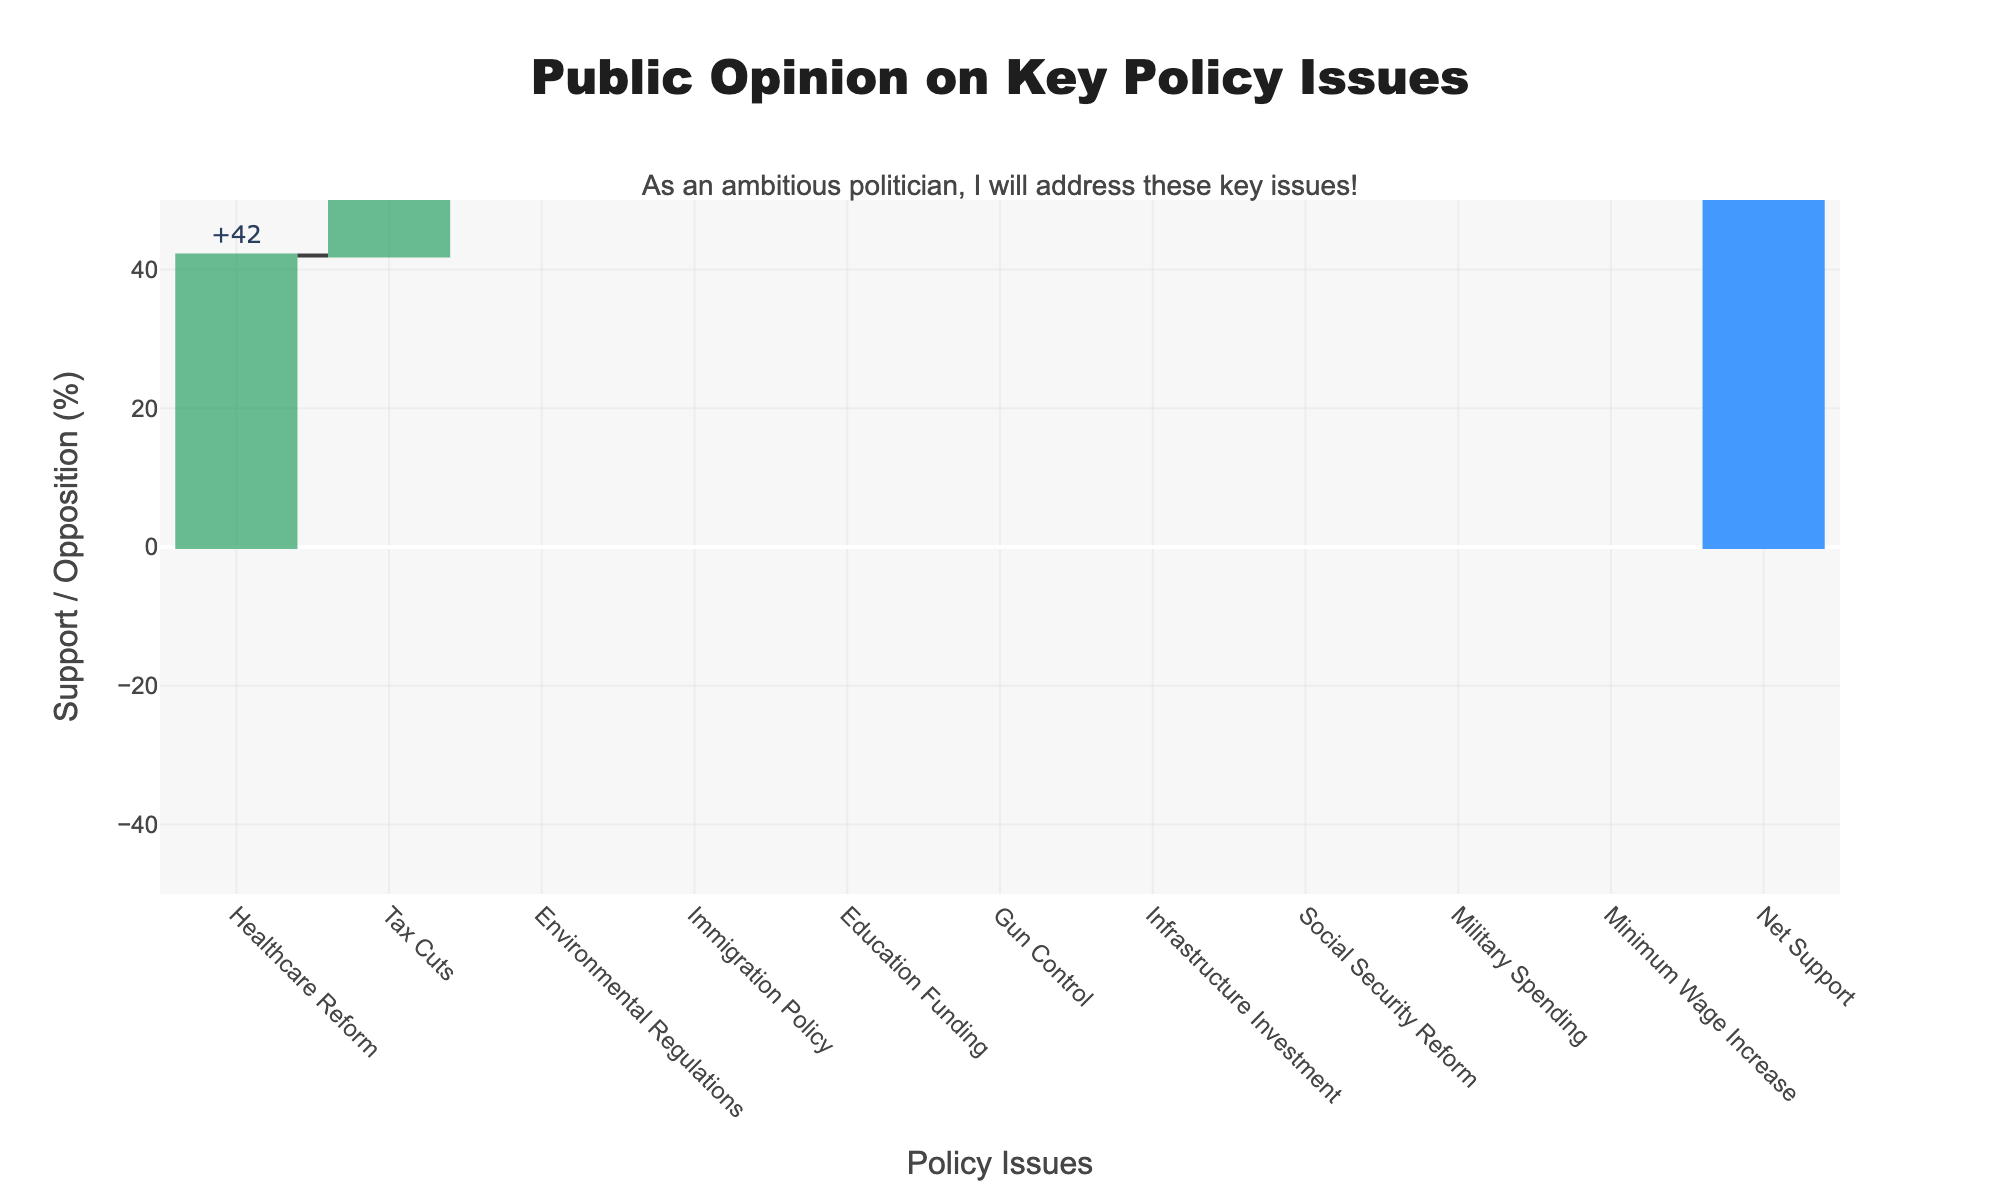What is the title of this chart? The title of the chart is located at the top center and reads "Public Opinion on Key Policy Issues".
Answer: Public Opinion on Key Policy Issues How many policy issues are shown in the figure? By counting the labels on the x-axis, we can see that there are ten policy issues listed.
Answer: Ten Which policy issue has the highest level of support? By comparing the green bars, which represent support, the tallest green bar corresponds to "Infrastructure Investment" with 48% support.
Answer: Infrastructure Investment What is the net support for "Immigration Policy"? Net support can be found by adding the support and opposition percentages for Immigration Policy. 31% (support) + (-39%) (opposition) = -8%.
Answer: -8% Is there any policy issue where opposition exceeds support? If so, name one. Analyzing the chart, we can see that "Gun Control" has a higher opposition value (-41%) compared to its support value (37%).
Answer: Gun Control What is the total net support across all policy issues? The total net support is provided in the last data point and can also be calculated by summing up the net support for all issues (Net Support). Total Net Support: (42 + 35 + 38 + 31 + 45 + 37 + 48 + 33 + 29 + 40) + (-38 -30 -33 -39 -25 -41 -22 -37 -34 -28) = 378 - 327 = 51%.
Answer: 51% Which policy issue has the closest net support to zero? By checking the hover text or calculating the net support for each issue, "Healthcare Reform" shows net support of 42% - 38% = 4%.
Answer: Healthcare Reform How does the total net support compare to the net support of "Minimum Wage Increase"? The total net support is 51%, while the net support for "Minimum Wage Increase" is 40% (support) + (-28%) (opposition) = 12%. Thus, the total net support is higher than "Minimum Wage Increase".
Answer: Total net support is higher Which policy issue has the lowest level of opposition? By comparing the red bars representing opposition, "Infrastructure Investment" has the shortest red bar with -22% opposition.
Answer: Infrastructure Investment Order the policy issues from highest to lowest net support. Calculate net support for each issue: Infrastructure Investment (26%), Education Funding (20%), Healthcare Reform (4%), Minimum Wage Increase (12%), Environmental Regulations (5%), Tax Cuts (5%), Gun Control (-4%), Social Security Reform (-4%), Immigration Policy (-8%), Military Spending (-5%). Ordered from highest to lowest: Infrastructure Investment, Education Funding, Minimum Wage Increase, Healthcare Reform, Environmental Regulations, Tax Cuts, Gun Control, Social Security Reform, Immigration Policy, Military Spending.
Answer: Infrastructure Investment, Education Funding, Minimum Wage Increase, Healthcare Reform, Environmental Regulations, Tax Cuts, Gun Control, Social Security Reform, Immigration Policy, Military Spending 